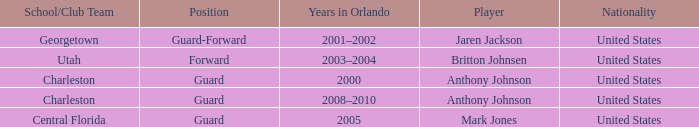What was the Position of the Player, Britton Johnsen? Forward. 